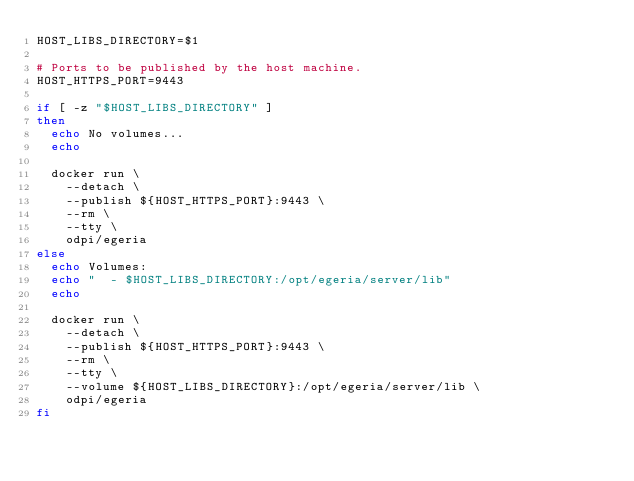Convert code to text. <code><loc_0><loc_0><loc_500><loc_500><_Bash_>HOST_LIBS_DIRECTORY=$1

# Ports to be published by the host machine.
HOST_HTTPS_PORT=9443

if [ -z "$HOST_LIBS_DIRECTORY" ]
then
  echo No volumes...
  echo

  docker run \
    --detach \
    --publish ${HOST_HTTPS_PORT}:9443 \
    --rm \
    --tty \
    odpi/egeria
else
  echo Volumes:
  echo "  - $HOST_LIBS_DIRECTORY:/opt/egeria/server/lib"
  echo

  docker run \
    --detach \
    --publish ${HOST_HTTPS_PORT}:9443 \
    --rm \
    --tty \
    --volume ${HOST_LIBS_DIRECTORY}:/opt/egeria/server/lib \
    odpi/egeria
fi
</code> 